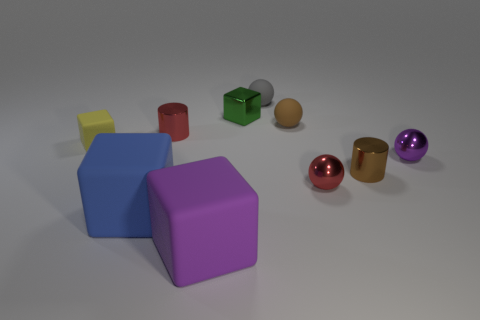What number of rubber things are red spheres or tiny purple objects? In this image, I see multiple colorful objects including a large red sphere, a small orange sphere, a tiny purple object amongst other items. There is one red sphere and one tiny purple object that fits the description. Therefore, the accurate answer is two items: one red sphere and one tiny purple object. 